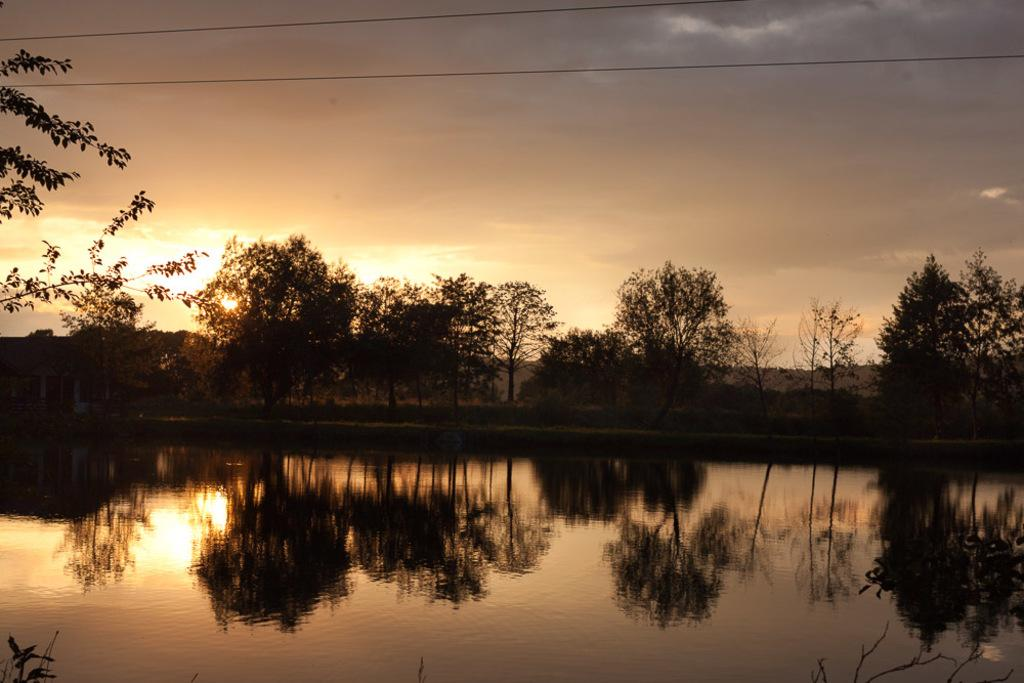What is located in the foreground of the image? There is a water body in the foreground of the image. What can be seen in the background of the image? There are trees and hills in the background of the image. What is the condition of the sky in the image? The sky is cloudy in the image. What feature of the water body is visible in the image? There is a reflection of the background on the water body. What type of food is being served in the image? There is no food present in the image; it features a water body, trees, hills, and a cloudy sky. Can you hear a bell ringing in the image? There is no bell present in the image, so it is not possible to hear it ringing. 